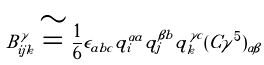Convert formula to latex. <formula><loc_0><loc_0><loc_500><loc_500>B _ { i j k } ^ { \gamma } \cong \frac { 1 } { 6 } \epsilon _ { a b c } q _ { i } ^ { \alpha a } q _ { j } ^ { \beta b } q _ { k } ^ { \gamma c } ( C \gamma ^ { 5 } ) _ { \alpha \beta }</formula> 